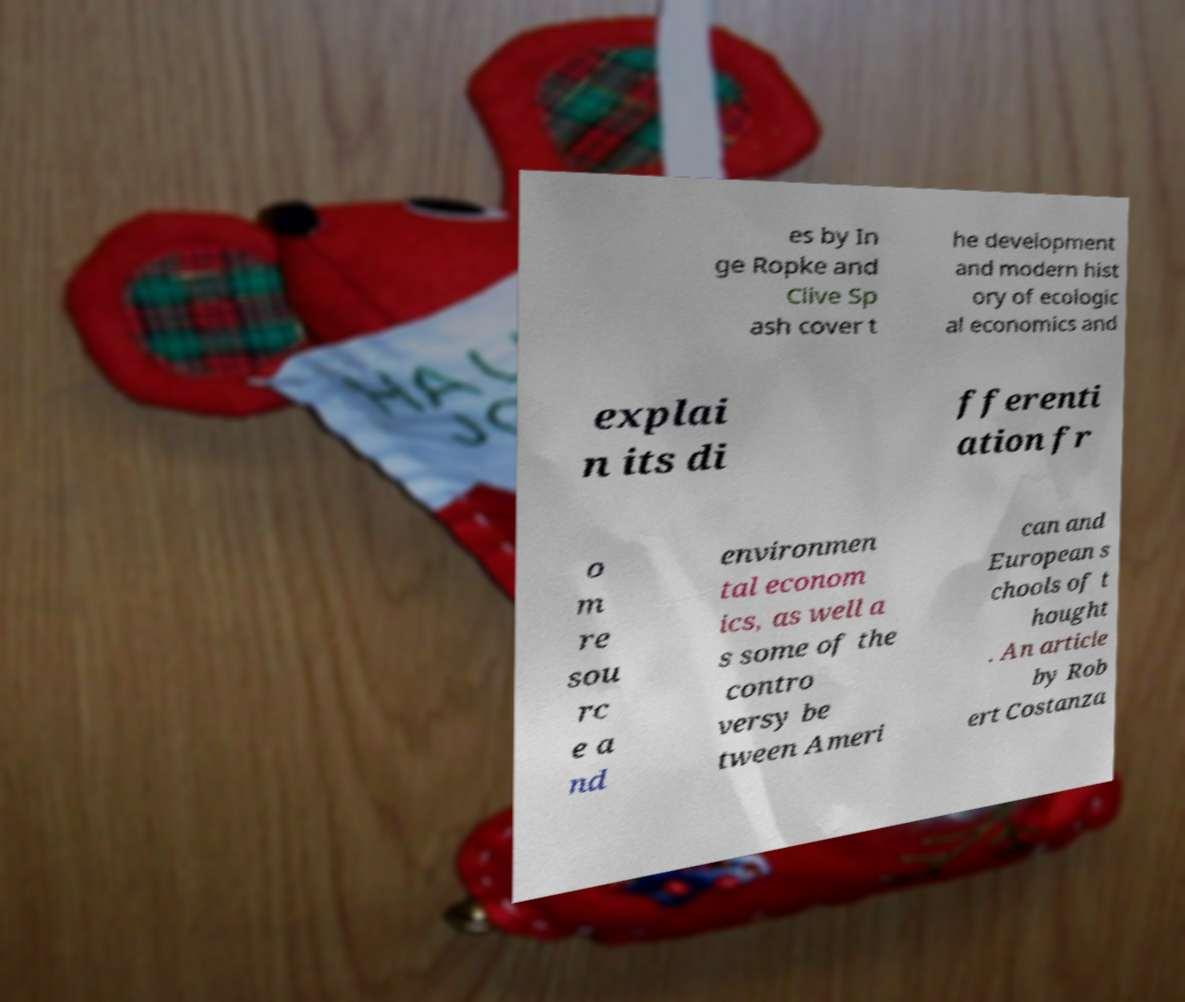There's text embedded in this image that I need extracted. Can you transcribe it verbatim? es by In ge Ropke and Clive Sp ash cover t he development and modern hist ory of ecologic al economics and explai n its di fferenti ation fr o m re sou rc e a nd environmen tal econom ics, as well a s some of the contro versy be tween Ameri can and European s chools of t hought . An article by Rob ert Costanza 